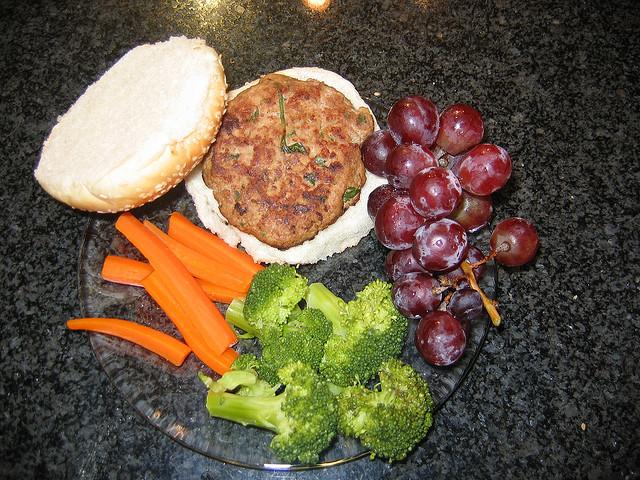How many different food groups are represented?
Quick response, please. 3. How many of these foods come from grain?
Give a very brief answer. 1. Have the grapes been properly washed?
Quick response, please. No. 